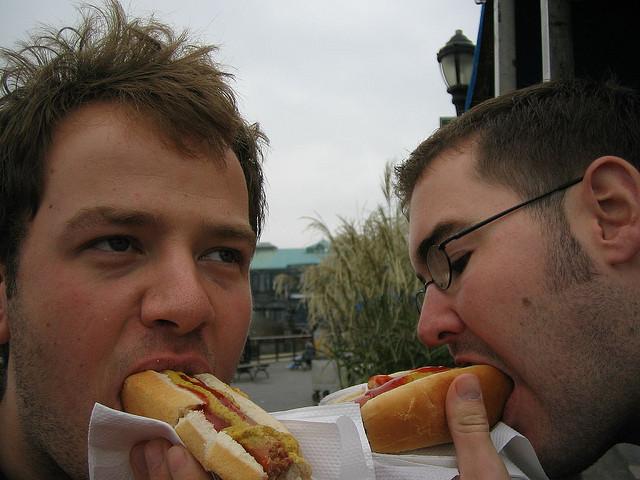What are these men eating?
Keep it brief. Hot dogs. How many people are eating?
Write a very short answer. 2. What toppings are on the hot dog?
Write a very short answer. Mustard and ketchup. Are these men happy?
Concise answer only. Yes. How many of these men are wearing glasses?
Answer briefly. 1. 